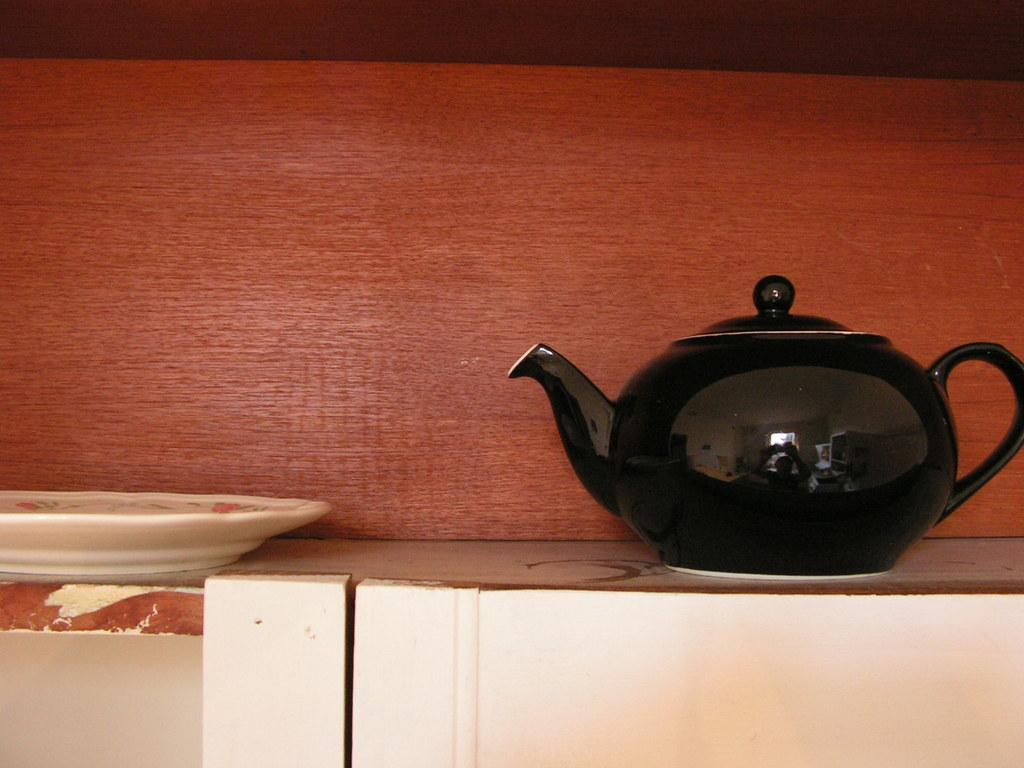What is on the table in the image? There is a pot and a plate on the table in the image. What else can be seen in the image besides the table? There is a wall visible in the image. What is the value of the frame around the pot in the image? There is no frame around the pot in the image, so it is not possible to determine its value. 